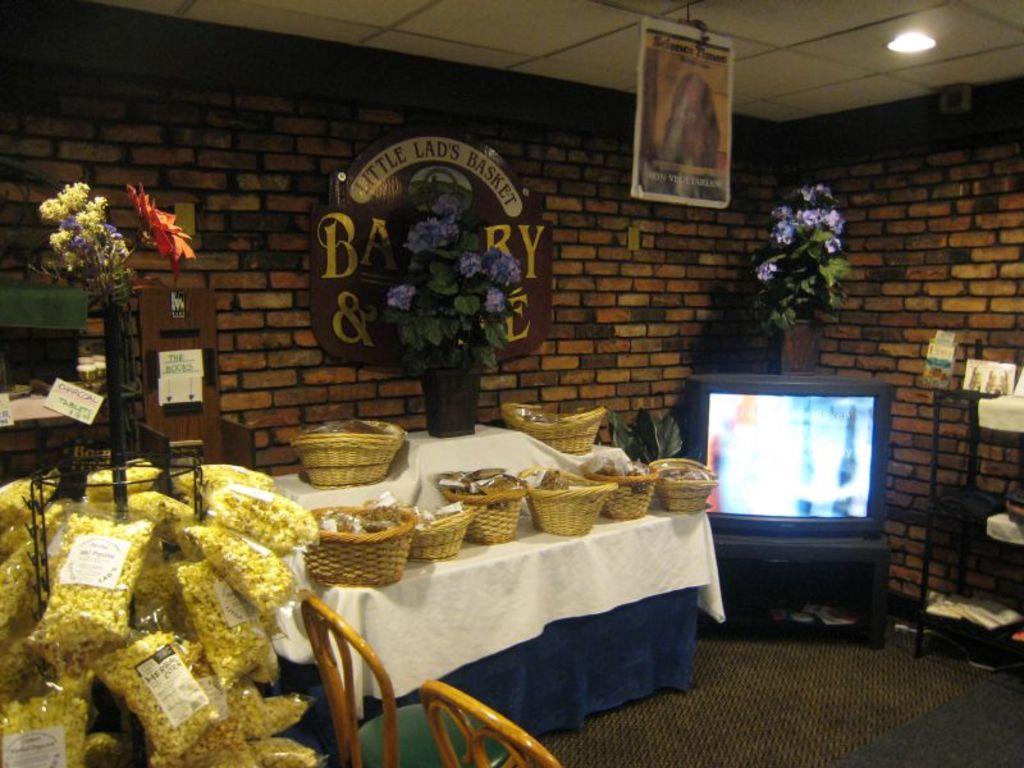Please provide a concise description of this image. It is a bakery there are many baskets with some groceries are kept on a table, on the left side there are popcorn packets and there are three flower vases in the room, on the right side there is a television and in the background there is a brick wall. 